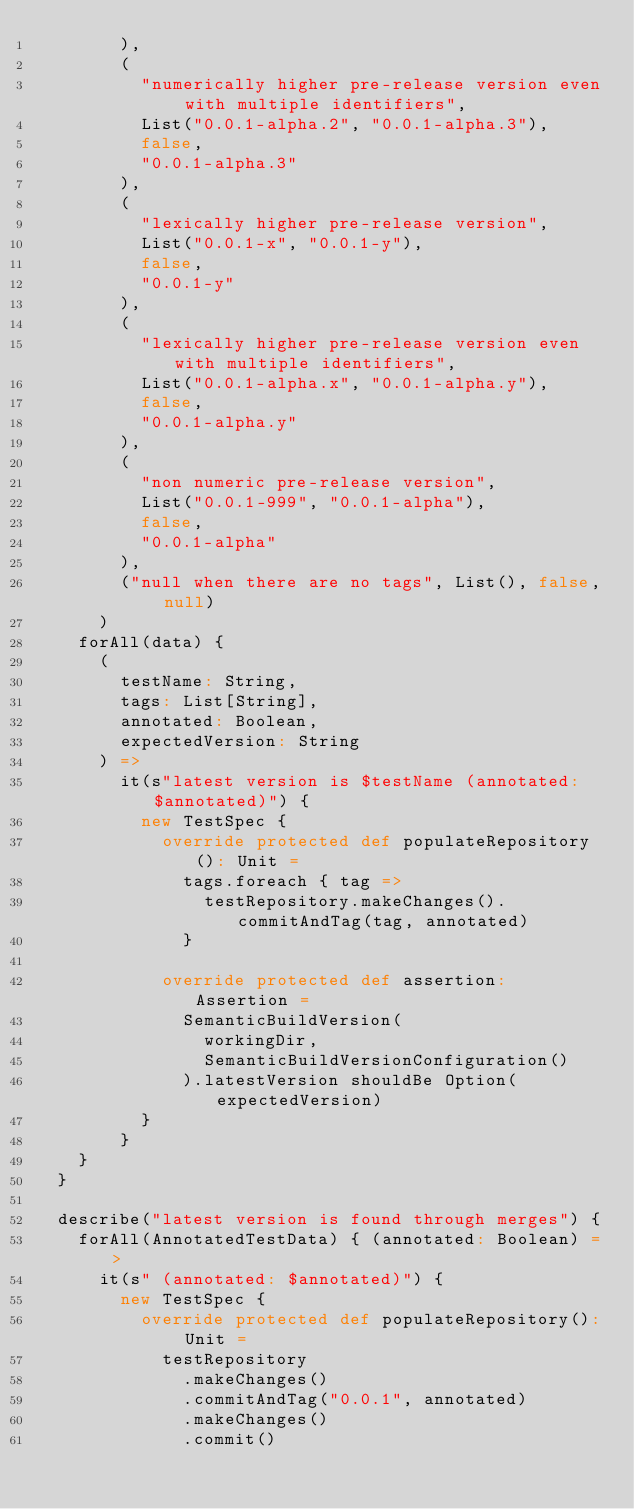<code> <loc_0><loc_0><loc_500><loc_500><_Scala_>        ),
        (
          "numerically higher pre-release version even with multiple identifiers",
          List("0.0.1-alpha.2", "0.0.1-alpha.3"),
          false,
          "0.0.1-alpha.3"
        ),
        (
          "lexically higher pre-release version",
          List("0.0.1-x", "0.0.1-y"),
          false,
          "0.0.1-y"
        ),
        (
          "lexically higher pre-release version even with multiple identifiers",
          List("0.0.1-alpha.x", "0.0.1-alpha.y"),
          false,
          "0.0.1-alpha.y"
        ),
        (
          "non numeric pre-release version",
          List("0.0.1-999", "0.0.1-alpha"),
          false,
          "0.0.1-alpha"
        ),
        ("null when there are no tags", List(), false, null)
      )
    forAll(data) {
      (
        testName: String,
        tags: List[String],
        annotated: Boolean,
        expectedVersion: String
      ) =>
        it(s"latest version is $testName (annotated: $annotated)") {
          new TestSpec {
            override protected def populateRepository(): Unit =
              tags.foreach { tag =>
                testRepository.makeChanges().commitAndTag(tag, annotated)
              }

            override protected def assertion: Assertion =
              SemanticBuildVersion(
                workingDir,
                SemanticBuildVersionConfiguration()
              ).latestVersion shouldBe Option(expectedVersion)
          }
        }
    }
  }

  describe("latest version is found through merges") {
    forAll(AnnotatedTestData) { (annotated: Boolean) =>
      it(s" (annotated: $annotated)") {
        new TestSpec {
          override protected def populateRepository(): Unit =
            testRepository
              .makeChanges()
              .commitAndTag("0.0.1", annotated)
              .makeChanges()
              .commit()</code> 